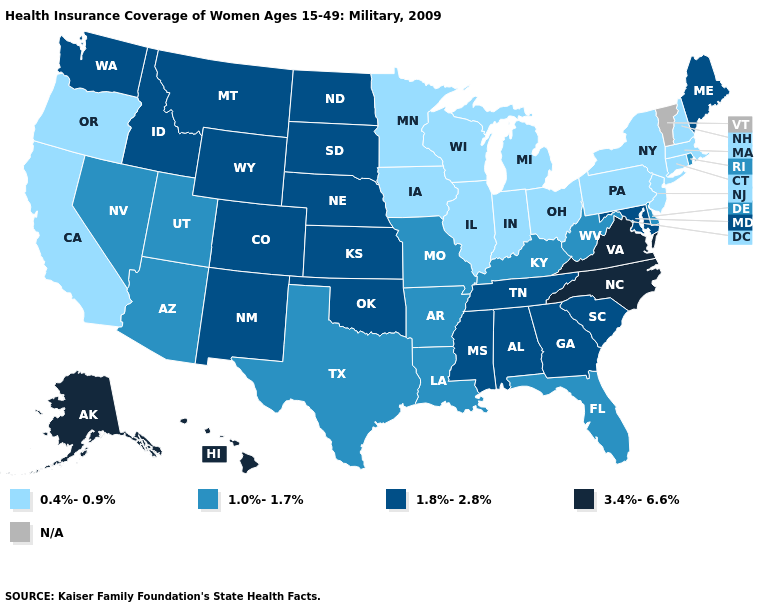Does Kansas have the highest value in the MidWest?
Answer briefly. Yes. Among the states that border Michigan , which have the highest value?
Concise answer only. Indiana, Ohio, Wisconsin. Does Virginia have the highest value in the USA?
Quick response, please. Yes. Name the states that have a value in the range 1.8%-2.8%?
Write a very short answer. Alabama, Colorado, Georgia, Idaho, Kansas, Maine, Maryland, Mississippi, Montana, Nebraska, New Mexico, North Dakota, Oklahoma, South Carolina, South Dakota, Tennessee, Washington, Wyoming. Does the first symbol in the legend represent the smallest category?
Short answer required. Yes. What is the lowest value in states that border Massachusetts?
Answer briefly. 0.4%-0.9%. Name the states that have a value in the range 1.8%-2.8%?
Be succinct. Alabama, Colorado, Georgia, Idaho, Kansas, Maine, Maryland, Mississippi, Montana, Nebraska, New Mexico, North Dakota, Oklahoma, South Carolina, South Dakota, Tennessee, Washington, Wyoming. Which states have the highest value in the USA?
Quick response, please. Alaska, Hawaii, North Carolina, Virginia. Which states have the lowest value in the South?
Be succinct. Arkansas, Delaware, Florida, Kentucky, Louisiana, Texas, West Virginia. Does Alaska have the highest value in the USA?
Answer briefly. Yes. What is the value of Oklahoma?
Quick response, please. 1.8%-2.8%. Which states hav the highest value in the Northeast?
Write a very short answer. Maine. 